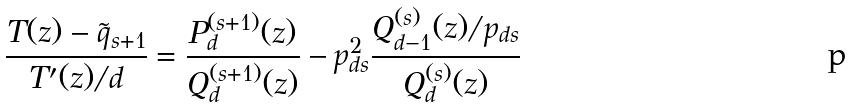Convert formula to latex. <formula><loc_0><loc_0><loc_500><loc_500>\frac { T ( z ) - \tilde { q } _ { s + 1 } } { T ^ { \prime } ( z ) / d } = \frac { P _ { d } ^ { ( s + 1 ) } ( z ) } { Q ^ { ( s + 1 ) } _ { d } ( z ) } - p _ { d s } ^ { 2 } \frac { Q _ { d - 1 } ^ { ( s ) } ( z ) / p _ { d s } } { Q ^ { ( s ) } _ { d } ( z ) }</formula> 